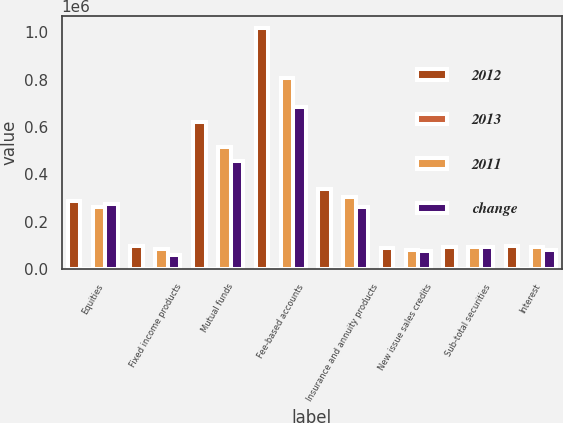Convert chart to OTSL. <chart><loc_0><loc_0><loc_500><loc_500><stacked_bar_chart><ecel><fcel>Equities<fcel>Fixed income products<fcel>Mutual funds<fcel>Fee-based accounts<fcel>Insurance and annuity products<fcel>New issue sales credits<fcel>Sub-total securities<fcel>Interest<nl><fcel>2012<fcel>289395<fcel>98994<fcel>621459<fcel>1.01634e+06<fcel>338666<fcel>90747<fcel>95866<fcel>96926<nl><fcel>2013<fcel>10<fcel>18<fcel>21<fcel>26<fcel>12<fcel>10<fcel>19<fcel>1<nl><fcel>2011<fcel>263578<fcel>83698<fcel>514146<fcel>808361<fcel>303628<fcel>82811<fcel>95866<fcel>95866<nl><fcel>change<fcel>276562<fcel>60193<fcel>458555<fcel>685672<fcel>261045<fcel>75590<fcel>95866<fcel>82272<nl></chart> 